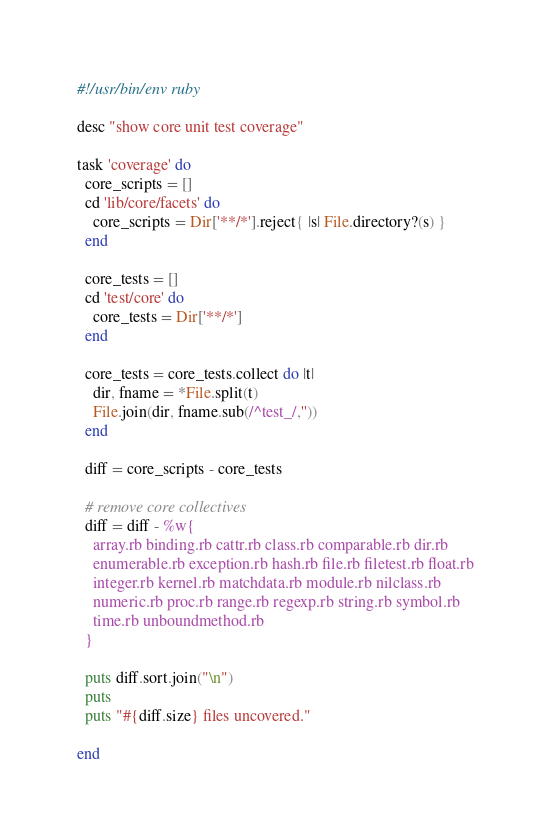<code> <loc_0><loc_0><loc_500><loc_500><_Ruby_>#!/usr/bin/env ruby

desc "show core unit test coverage"

task 'coverage' do
  core_scripts = []
  cd 'lib/core/facets' do
    core_scripts = Dir['**/*'].reject{ |s| File.directory?(s) }
  end

  core_tests = []
  cd 'test/core' do
    core_tests = Dir['**/*']
  end

  core_tests = core_tests.collect do |t|
    dir, fname = *File.split(t)
    File.join(dir, fname.sub(/^test_/,''))
  end

  diff = core_scripts - core_tests

  # remove core collectives
  diff = diff - %w{
    array.rb binding.rb cattr.rb class.rb comparable.rb dir.rb
    enumerable.rb exception.rb hash.rb file.rb filetest.rb float.rb
    integer.rb kernel.rb matchdata.rb module.rb nilclass.rb
    numeric.rb proc.rb range.rb regexp.rb string.rb symbol.rb
    time.rb unboundmethod.rb
  }

  puts diff.sort.join("\n")
  puts
  puts "#{diff.size} files uncovered."

end

</code> 